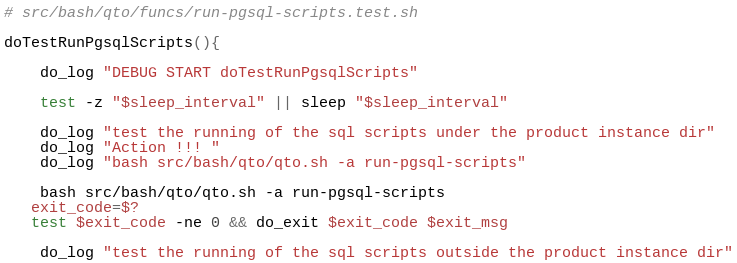<code> <loc_0><loc_0><loc_500><loc_500><_Bash_># src/bash/qto/funcs/run-pgsql-scripts.test.sh

doTestRunPgsqlScripts(){

	do_log "DEBUG START doTestRunPgsqlScripts"
	
	test -z "$sleep_interval" || sleep "$sleep_interval"

	do_log "test the running of the sql scripts under the product instance dir"
	do_log "Action !!! "
	do_log "bash src/bash/qto/qto.sh -a run-pgsql-scripts"

	bash src/bash/qto/qto.sh -a run-pgsql-scripts
   exit_code=$?
   test $exit_code -ne 0 && do_exit $exit_code $exit_msg
   
	do_log "test the running of the sql scripts outside the product instance dir"</code> 